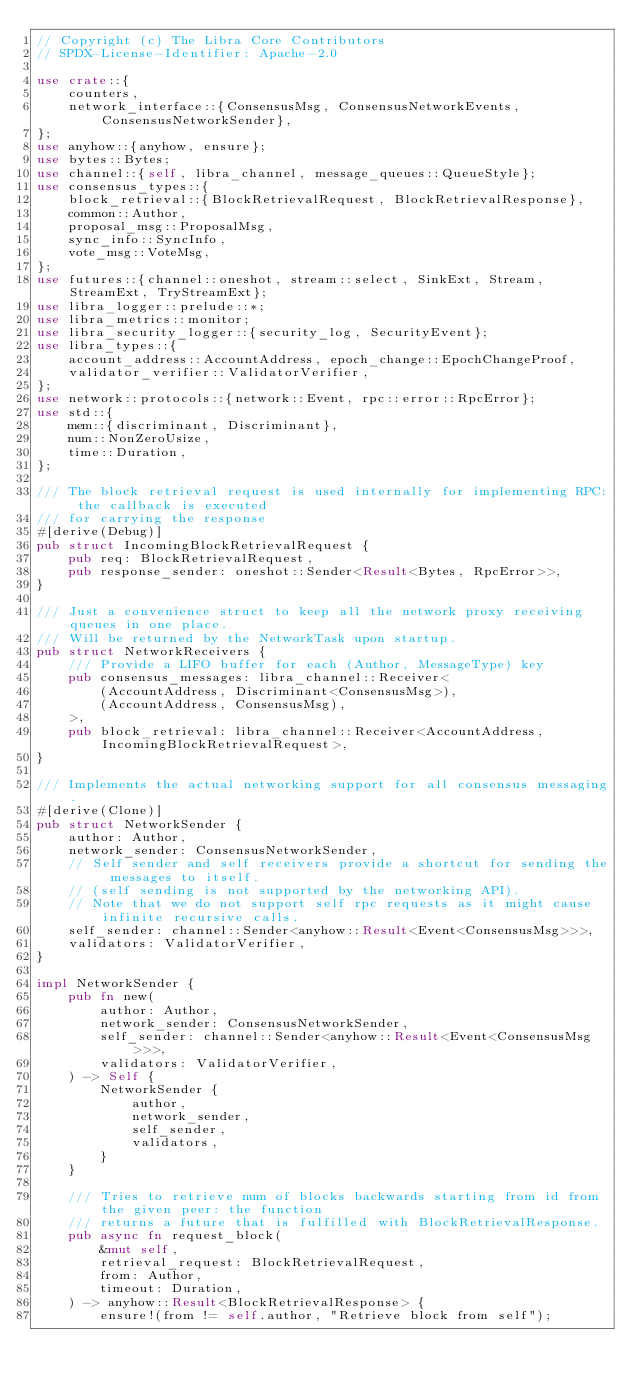Convert code to text. <code><loc_0><loc_0><loc_500><loc_500><_Rust_>// Copyright (c) The Libra Core Contributors
// SPDX-License-Identifier: Apache-2.0

use crate::{
    counters,
    network_interface::{ConsensusMsg, ConsensusNetworkEvents, ConsensusNetworkSender},
};
use anyhow::{anyhow, ensure};
use bytes::Bytes;
use channel::{self, libra_channel, message_queues::QueueStyle};
use consensus_types::{
    block_retrieval::{BlockRetrievalRequest, BlockRetrievalResponse},
    common::Author,
    proposal_msg::ProposalMsg,
    sync_info::SyncInfo,
    vote_msg::VoteMsg,
};
use futures::{channel::oneshot, stream::select, SinkExt, Stream, StreamExt, TryStreamExt};
use libra_logger::prelude::*;
use libra_metrics::monitor;
use libra_security_logger::{security_log, SecurityEvent};
use libra_types::{
    account_address::AccountAddress, epoch_change::EpochChangeProof,
    validator_verifier::ValidatorVerifier,
};
use network::protocols::{network::Event, rpc::error::RpcError};
use std::{
    mem::{discriminant, Discriminant},
    num::NonZeroUsize,
    time::Duration,
};

/// The block retrieval request is used internally for implementing RPC: the callback is executed
/// for carrying the response
#[derive(Debug)]
pub struct IncomingBlockRetrievalRequest {
    pub req: BlockRetrievalRequest,
    pub response_sender: oneshot::Sender<Result<Bytes, RpcError>>,
}

/// Just a convenience struct to keep all the network proxy receiving queues in one place.
/// Will be returned by the NetworkTask upon startup.
pub struct NetworkReceivers {
    /// Provide a LIFO buffer for each (Author, MessageType) key
    pub consensus_messages: libra_channel::Receiver<
        (AccountAddress, Discriminant<ConsensusMsg>),
        (AccountAddress, ConsensusMsg),
    >,
    pub block_retrieval: libra_channel::Receiver<AccountAddress, IncomingBlockRetrievalRequest>,
}

/// Implements the actual networking support for all consensus messaging.
#[derive(Clone)]
pub struct NetworkSender {
    author: Author,
    network_sender: ConsensusNetworkSender,
    // Self sender and self receivers provide a shortcut for sending the messages to itself.
    // (self sending is not supported by the networking API).
    // Note that we do not support self rpc requests as it might cause infinite recursive calls.
    self_sender: channel::Sender<anyhow::Result<Event<ConsensusMsg>>>,
    validators: ValidatorVerifier,
}

impl NetworkSender {
    pub fn new(
        author: Author,
        network_sender: ConsensusNetworkSender,
        self_sender: channel::Sender<anyhow::Result<Event<ConsensusMsg>>>,
        validators: ValidatorVerifier,
    ) -> Self {
        NetworkSender {
            author,
            network_sender,
            self_sender,
            validators,
        }
    }

    /// Tries to retrieve num of blocks backwards starting from id from the given peer: the function
    /// returns a future that is fulfilled with BlockRetrievalResponse.
    pub async fn request_block(
        &mut self,
        retrieval_request: BlockRetrievalRequest,
        from: Author,
        timeout: Duration,
    ) -> anyhow::Result<BlockRetrievalResponse> {
        ensure!(from != self.author, "Retrieve block from self");</code> 